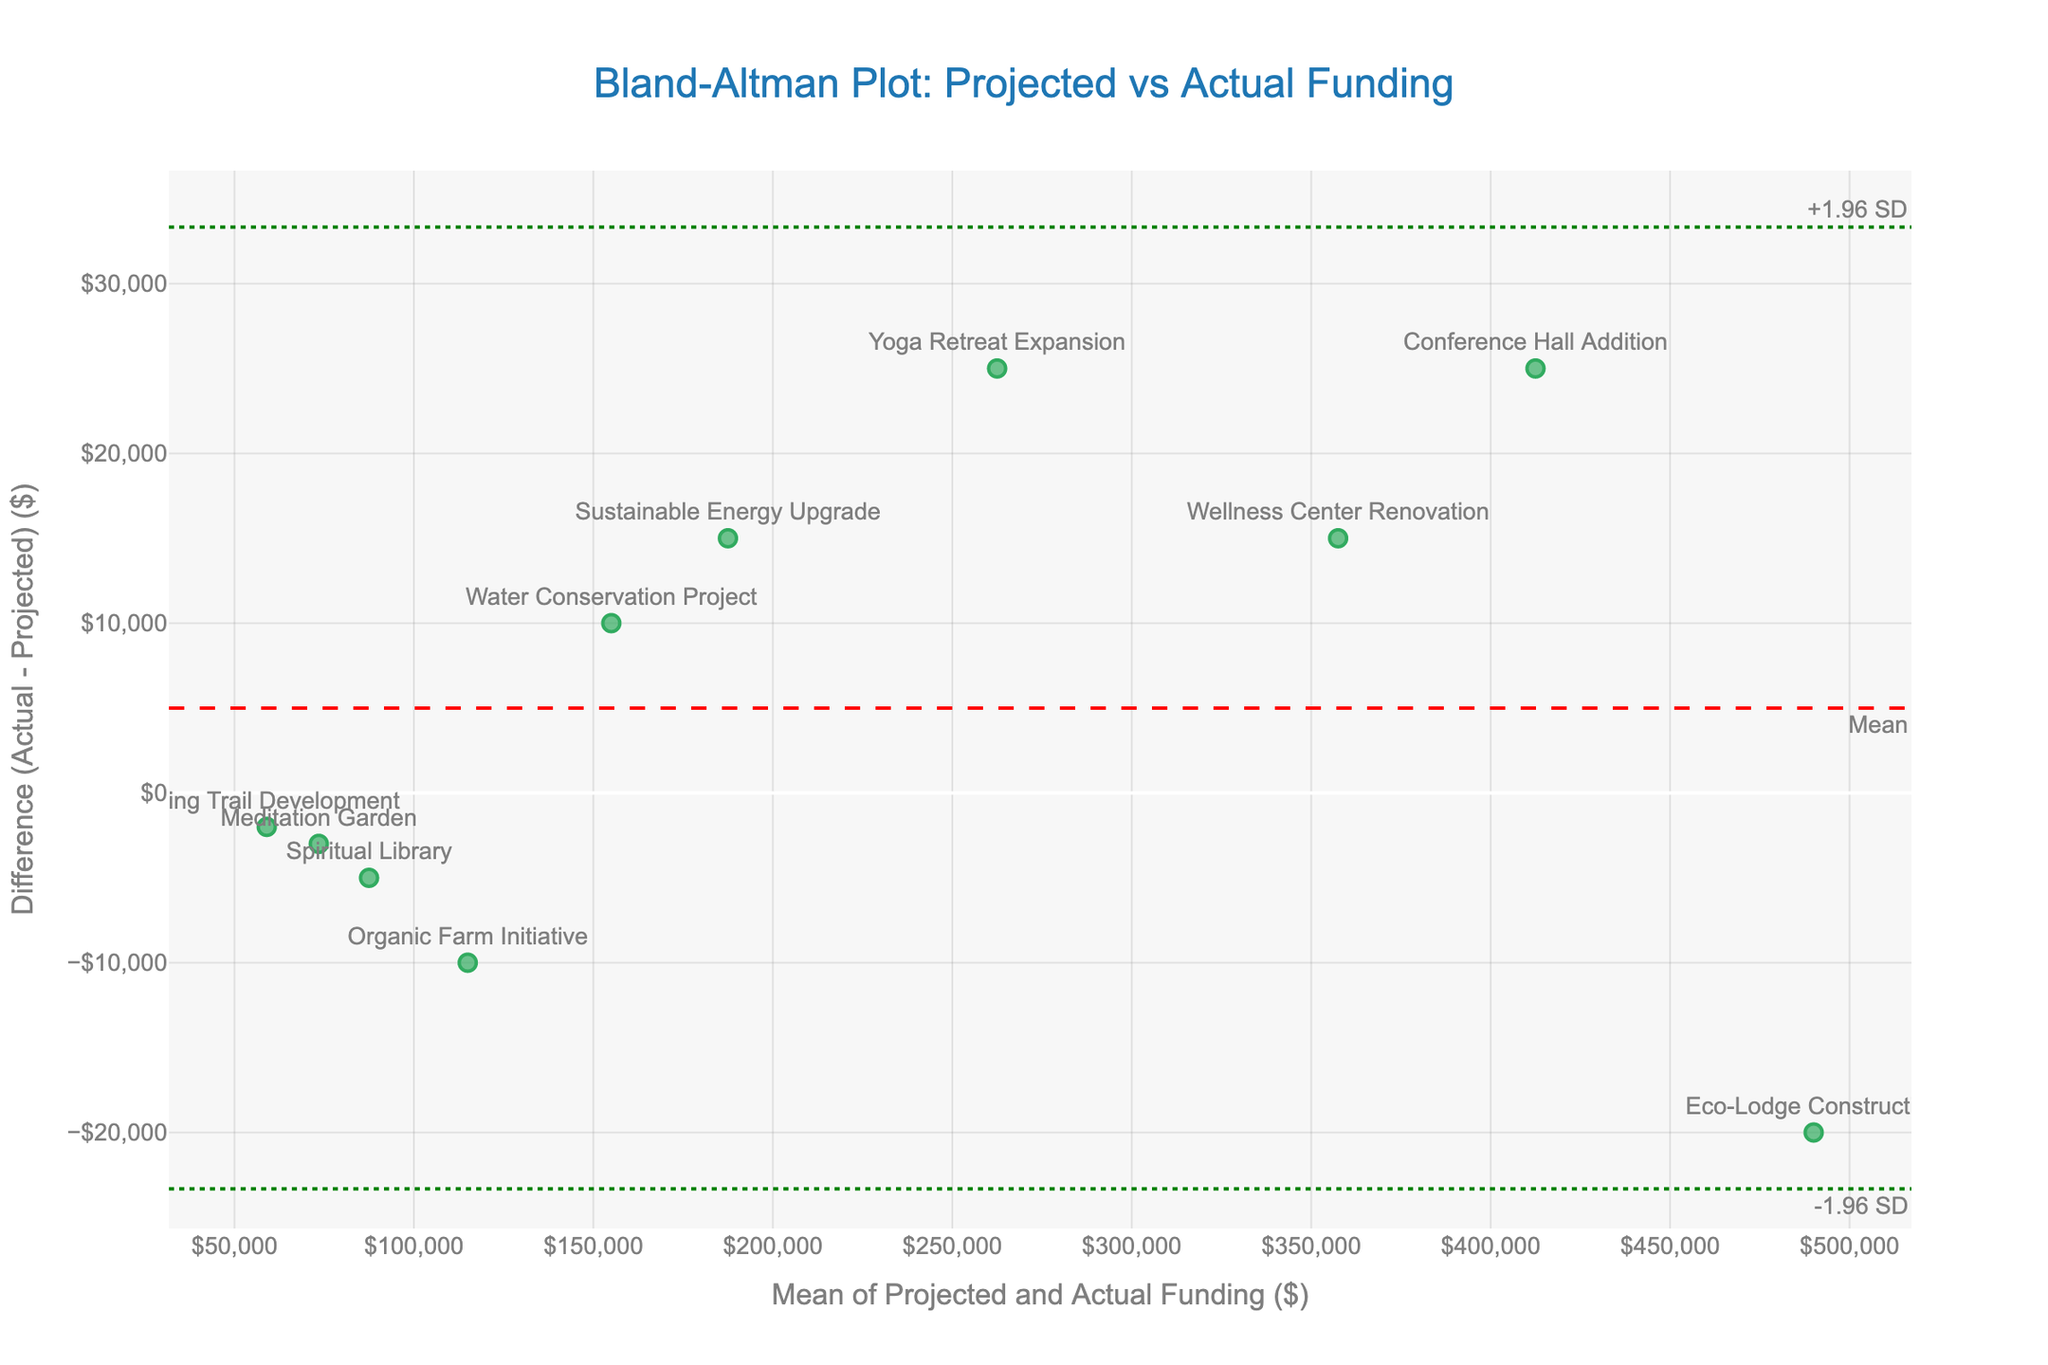What is the title of the plot? The title is usually positioned at the top of the plot and gives an overview of what the plot represents. In this case, it is clearly written to describe the Bland-Altman analysis being shown.
Answer: Bland-Altman Plot: Projected vs Actual Funding What do the x-axis and y-axis represent? The axes labels give essential contextual information about the data being plotted. The x-axis represents the mean funding amount (average of projected and actual), and the y-axis represents the difference in funding (actual minus projected).
Answer: Mean of Projected and Actual Funding ($) and Difference (Actual - Projected) ($) Which project had the highest positive difference between actual and projected funding? Observing the scatter points, focus on the y-axis to find the point furthest above the zero line. The associated hover text or text label will denote the project with the highest positive difference.
Answer: Conference Hall Addition What are the green dashed lines on the plot representing? Green dashed lines in a Bland-Altman plot usually represent the limits of agreement. These lines are set at ±1.96 standard deviations from the mean difference, indicating where most differences between actual and projected funding amounts should fall.
Answer: Limits of agreement (+1.96 SD and -1.96 SD) What is the mean difference for the funding amounts? The mean difference line is typically annotated in red on the plot. The y-coordinate of this red dashed line tells us the mean difference.
Answer: Approximately 6,700 Is there any project where the actual funding was less than the projected funding? Scan the plot to find data points below the zero line on the y-axis. These points indicate cases where actual funding was less than projected. Looking at the text labels or hover information will identify the projects.
Answer: Eco-Lodge Construction and Organic Farm Initiative What is the range of the y-axis in terms of the funding differences? Check the y-axis limits to determine the minimum and maximum values plotted, which embody the full range of funding differences.
Answer: Approximately -20,000 to 33,000 Which project showed the smallest difference between projected and actual funding? Locate the point closest to the zero line on the y-axis. The text label or hover text of this point reveals the associated project.
Answer: Hiking Trail Development Is there any outlier beyond the limits of agreement in the plot? Outliers in a Bland-Altman plot are points outside the green dashed lines of ±1.96 standard deviations. Observe if any points fall outside these lines.
Answer: No 